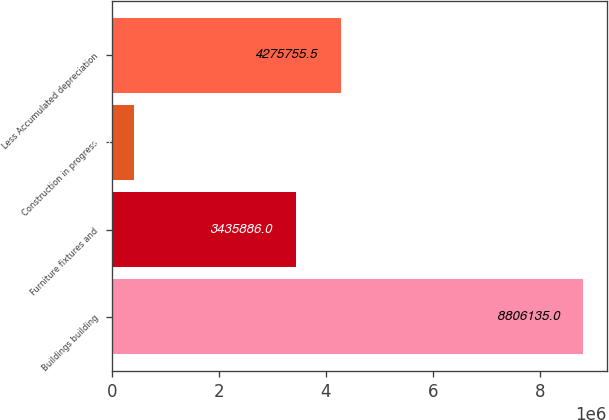<chart> <loc_0><loc_0><loc_500><loc_500><bar_chart><fcel>Buildings building<fcel>Furniture fixtures and<fcel>Construction in progress<fcel>Less Accumulated depreciation<nl><fcel>8.80614e+06<fcel>3.43589e+06<fcel>407440<fcel>4.27576e+06<nl></chart> 